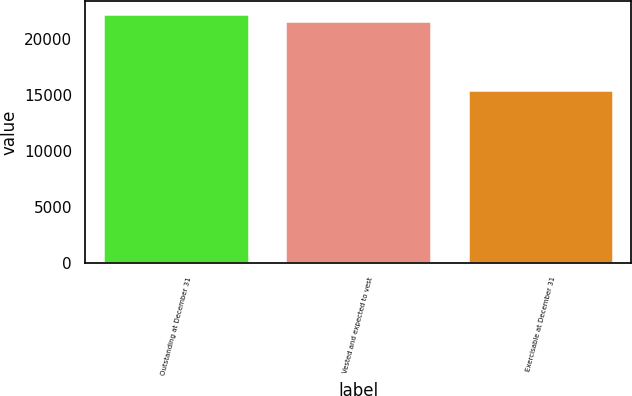Convert chart. <chart><loc_0><loc_0><loc_500><loc_500><bar_chart><fcel>Outstanding at December 31<fcel>Vested and expected to vest<fcel>Exercisable at December 31<nl><fcel>22286.4<fcel>21632<fcel>15503<nl></chart> 